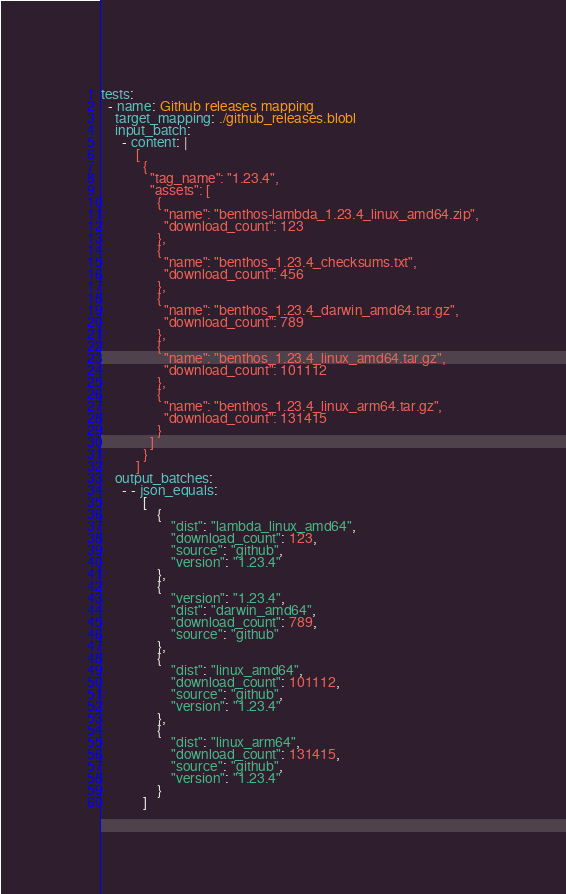Convert code to text. <code><loc_0><loc_0><loc_500><loc_500><_YAML_>tests:
  - name: Github releases mapping
    target_mapping: ./github_releases.blobl
    input_batch:
      - content: |
          [
            {
              "tag_name": "1.23.4",
              "assets": [
                {
                  "name": "benthos-lambda_1.23.4_linux_amd64.zip",
                  "download_count": 123
                },
                {
                  "name": "benthos_1.23.4_checksums.txt",
                  "download_count": 456
                },
                {
                  "name": "benthos_1.23.4_darwin_amd64.tar.gz",
                  "download_count": 789
                },
                {
                  "name": "benthos_1.23.4_linux_amd64.tar.gz",
                  "download_count": 101112
                },
                {
                  "name": "benthos_1.23.4_linux_arm64.tar.gz",
                  "download_count": 131415
                }
              ]
            }
          ]
    output_batches:
      - - json_equals:
            [
                {
                    "dist": "lambda_linux_amd64",
                    "download_count": 123,
                    "source": "github",
                    "version": "1.23.4"
                },
                {
                    "version": "1.23.4",
                    "dist": "darwin_amd64",
                    "download_count": 789,
                    "source": "github"
                },
                {
                    "dist": "linux_amd64",
                    "download_count": 101112,
                    "source": "github",
                    "version": "1.23.4"
                },
                {
                    "dist": "linux_arm64",
                    "download_count": 131415,
                    "source": "github",
                    "version": "1.23.4"
                }
            ]
</code> 